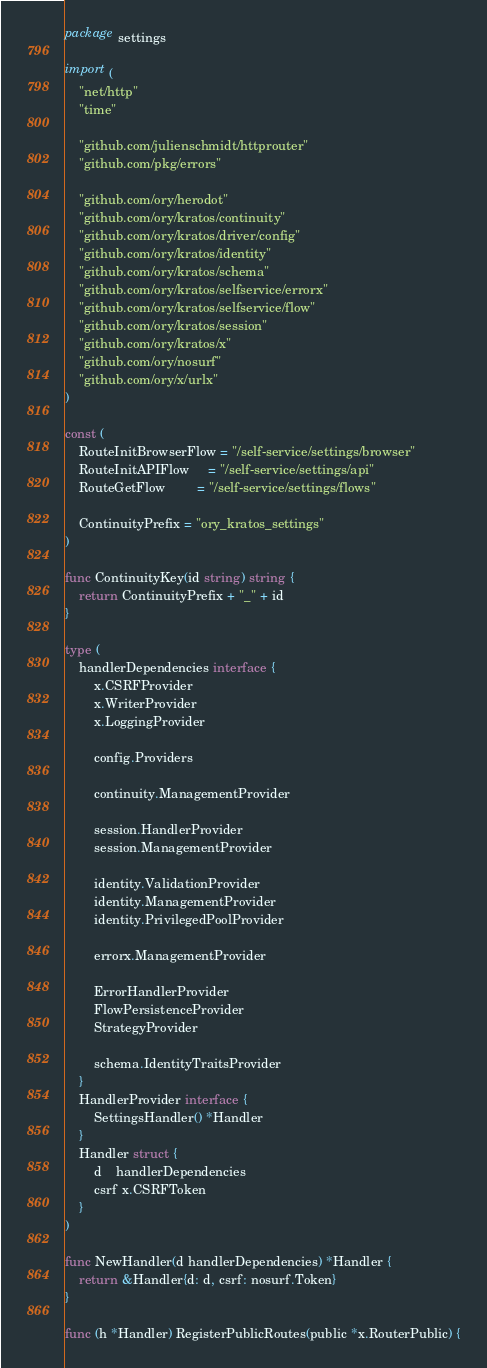Convert code to text. <code><loc_0><loc_0><loc_500><loc_500><_Go_>package settings

import (
	"net/http"
	"time"

	"github.com/julienschmidt/httprouter"
	"github.com/pkg/errors"

	"github.com/ory/herodot"
	"github.com/ory/kratos/continuity"
	"github.com/ory/kratos/driver/config"
	"github.com/ory/kratos/identity"
	"github.com/ory/kratos/schema"
	"github.com/ory/kratos/selfservice/errorx"
	"github.com/ory/kratos/selfservice/flow"
	"github.com/ory/kratos/session"
	"github.com/ory/kratos/x"
	"github.com/ory/nosurf"
	"github.com/ory/x/urlx"
)

const (
	RouteInitBrowserFlow = "/self-service/settings/browser"
	RouteInitAPIFlow     = "/self-service/settings/api"
	RouteGetFlow         = "/self-service/settings/flows"

	ContinuityPrefix = "ory_kratos_settings"
)

func ContinuityKey(id string) string {
	return ContinuityPrefix + "_" + id
}

type (
	handlerDependencies interface {
		x.CSRFProvider
		x.WriterProvider
		x.LoggingProvider

		config.Providers

		continuity.ManagementProvider

		session.HandlerProvider
		session.ManagementProvider

		identity.ValidationProvider
		identity.ManagementProvider
		identity.PrivilegedPoolProvider

		errorx.ManagementProvider

		ErrorHandlerProvider
		FlowPersistenceProvider
		StrategyProvider

		schema.IdentityTraitsProvider
	}
	HandlerProvider interface {
		SettingsHandler() *Handler
	}
	Handler struct {
		d    handlerDependencies
		csrf x.CSRFToken
	}
)

func NewHandler(d handlerDependencies) *Handler {
	return &Handler{d: d, csrf: nosurf.Token}
}

func (h *Handler) RegisterPublicRoutes(public *x.RouterPublic) {</code> 